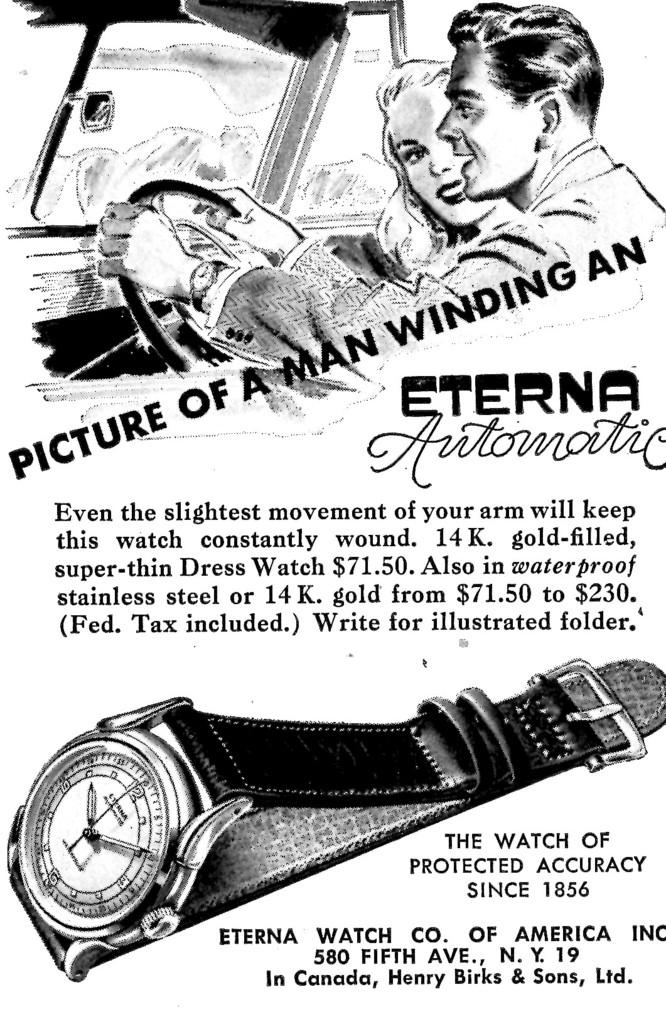<image>
Provide a brief description of the given image. A black and white advertisement for Eterna Automatic watch company. 